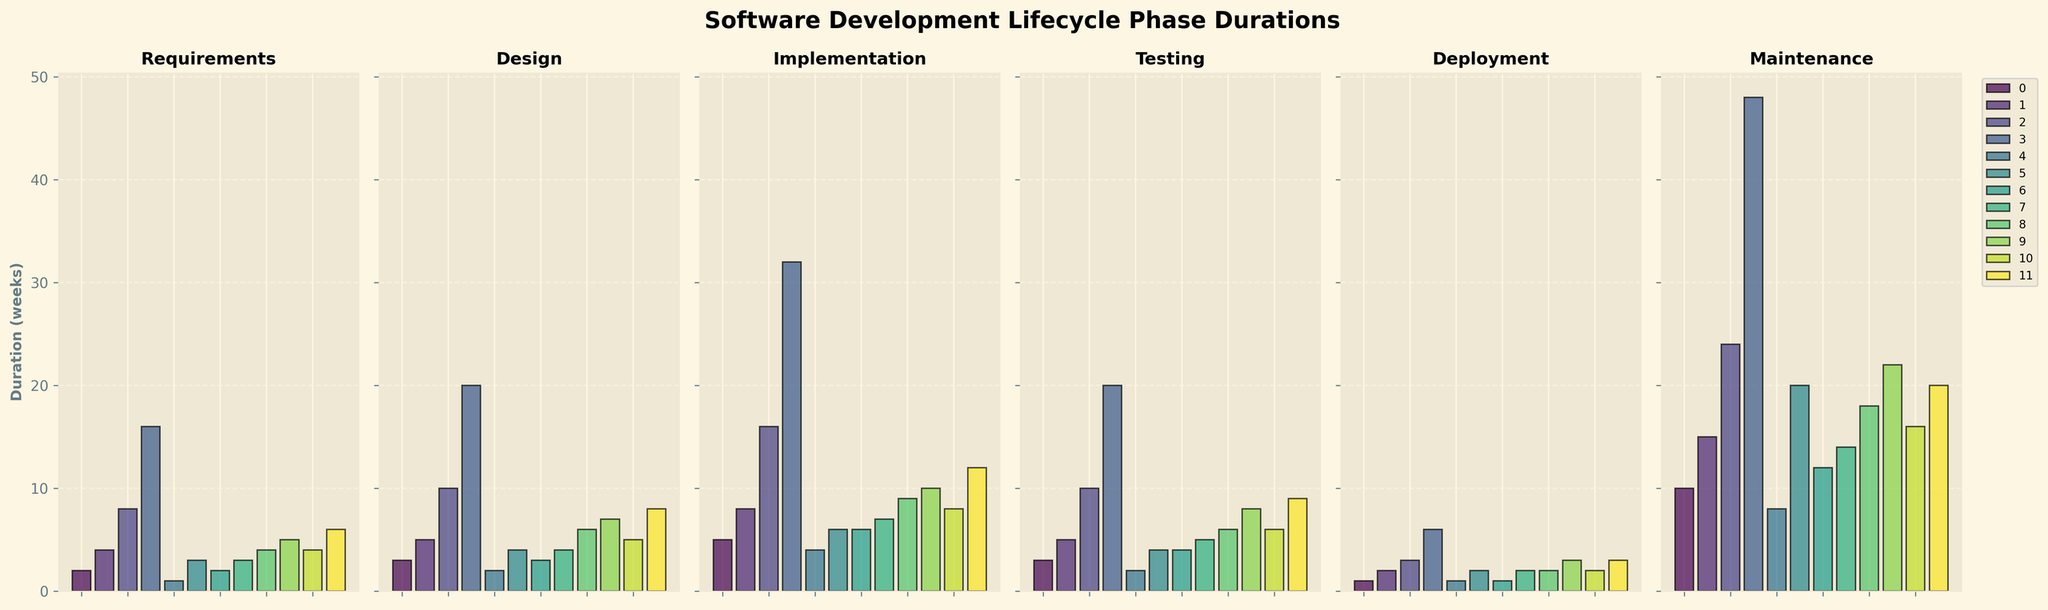What phase has the longest duration for Enterprise projects? Look at the bar heights for the Enterprise project in each subplot and identify the tallest bar. The Maintenance phase has the tallest bar.
Answer: Maintenance Which project size has the shortest duration for the Deployment phase? Compare all bar heights in the Deployment subplot and find the shortest one. The Startup project has the shortest bar.
Answer: Startup What's the total duration of all phases for the Large project? Sum the durations of all phases for the Large project: (8 + 10 + 16 + 10 + 3 + 24) = 71.
Answer: 71 Which phase exhibits the most variation in duration across different project sizes? Compare the range (difference between longest and shortest bar) for all phases. The Maintenance phase has the most significant difference (48 - 8 = 40).
Answer: Maintenance What's the difference in Implementation duration between a Small and an Enterprise project? Find the bar heights in the Implementation subplot for Small (5) and Enterprise (32) projects. The difference 32 - 5 = 27.
Answer: 27 How does the Testing duration of a Web Application compare to that of a Desktop Application? Check the bar heights for Web Application (5) and Desktop Application (6) in the Testing subplot. The Desktop Application has a slightly higher bar.
Answer: Desktop Application is higher Which project sizes have an equal duration for the Deployment phase? Look for bars of the same height in the Deployment subplot. Small, Startup, and Mobile App all have a duration of 1 week.
Answer: Small, Startup, Mobile App Is there a project size that has a higher Design phase duration than Implementation duration? Compare the bar heights in the Design and Implementation subplots. All projects have a higher or equal Implementation duration compared to their Design duration.
Answer: None 